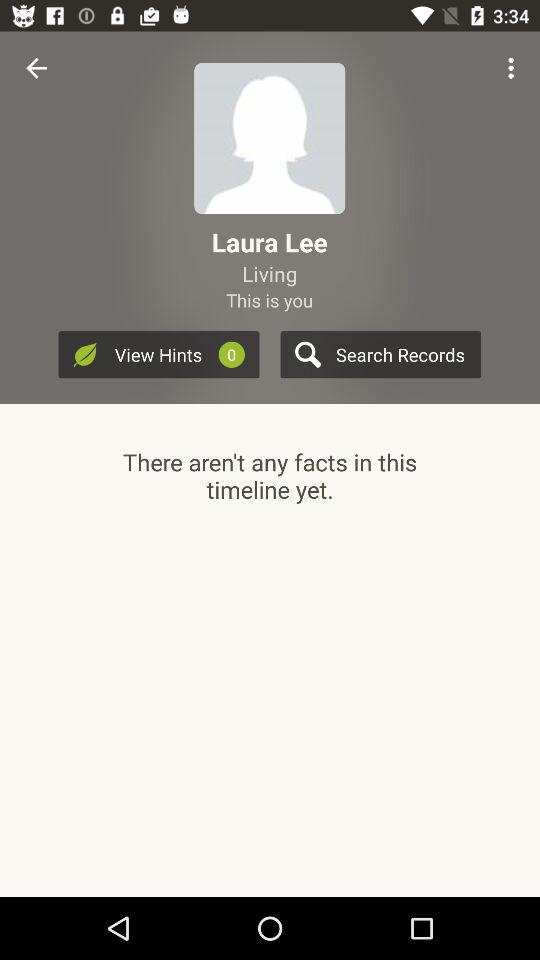What is the user name? The user name is Laura Lee. 